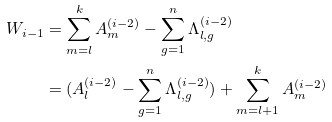Convert formula to latex. <formula><loc_0><loc_0><loc_500><loc_500>W _ { i - 1 } & = \sum _ { m = l } ^ { k } A _ { m } ^ { ( i - 2 ) } - \sum _ { g = 1 } ^ { n } \Lambda _ { l , g } ^ { ( i - 2 ) } \\ & = ( A _ { l } ^ { ( i - 2 ) } - \sum _ { g = 1 } ^ { n } \Lambda _ { l , g } ^ { ( i - 2 ) } ) + \sum _ { m = l + 1 } ^ { k } A _ { m } ^ { ( i - 2 ) }</formula> 